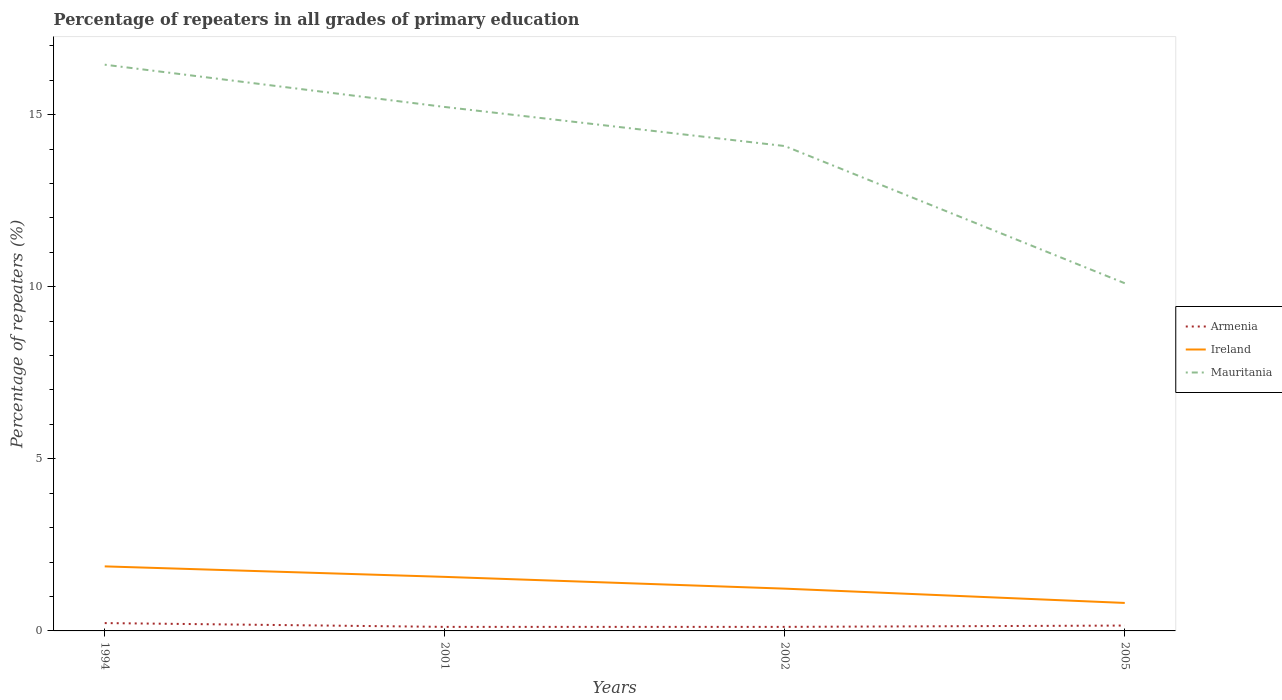Does the line corresponding to Ireland intersect with the line corresponding to Mauritania?
Give a very brief answer. No. Across all years, what is the maximum percentage of repeaters in Ireland?
Provide a short and direct response. 0.81. In which year was the percentage of repeaters in Ireland maximum?
Provide a short and direct response. 2005. What is the total percentage of repeaters in Ireland in the graph?
Make the answer very short. 0.3. What is the difference between the highest and the second highest percentage of repeaters in Ireland?
Your response must be concise. 1.06. What is the difference between the highest and the lowest percentage of repeaters in Ireland?
Ensure brevity in your answer.  2. How many lines are there?
Make the answer very short. 3. What is the difference between two consecutive major ticks on the Y-axis?
Offer a terse response. 5. Does the graph contain grids?
Ensure brevity in your answer.  No. Where does the legend appear in the graph?
Offer a terse response. Center right. How many legend labels are there?
Keep it short and to the point. 3. What is the title of the graph?
Ensure brevity in your answer.  Percentage of repeaters in all grades of primary education. Does "Comoros" appear as one of the legend labels in the graph?
Keep it short and to the point. No. What is the label or title of the X-axis?
Your answer should be compact. Years. What is the label or title of the Y-axis?
Provide a succinct answer. Percentage of repeaters (%). What is the Percentage of repeaters (%) in Armenia in 1994?
Give a very brief answer. 0.23. What is the Percentage of repeaters (%) of Ireland in 1994?
Provide a succinct answer. 1.88. What is the Percentage of repeaters (%) of Mauritania in 1994?
Make the answer very short. 16.45. What is the Percentage of repeaters (%) of Armenia in 2001?
Offer a very short reply. 0.12. What is the Percentage of repeaters (%) of Ireland in 2001?
Provide a short and direct response. 1.57. What is the Percentage of repeaters (%) in Mauritania in 2001?
Provide a short and direct response. 15.22. What is the Percentage of repeaters (%) in Armenia in 2002?
Provide a short and direct response. 0.12. What is the Percentage of repeaters (%) of Ireland in 2002?
Keep it short and to the point. 1.23. What is the Percentage of repeaters (%) of Mauritania in 2002?
Ensure brevity in your answer.  14.09. What is the Percentage of repeaters (%) of Armenia in 2005?
Your answer should be very brief. 0.16. What is the Percentage of repeaters (%) of Ireland in 2005?
Your answer should be compact. 0.81. What is the Percentage of repeaters (%) in Mauritania in 2005?
Your response must be concise. 10.1. Across all years, what is the maximum Percentage of repeaters (%) in Armenia?
Provide a succinct answer. 0.23. Across all years, what is the maximum Percentage of repeaters (%) of Ireland?
Provide a short and direct response. 1.88. Across all years, what is the maximum Percentage of repeaters (%) in Mauritania?
Offer a very short reply. 16.45. Across all years, what is the minimum Percentage of repeaters (%) in Armenia?
Make the answer very short. 0.12. Across all years, what is the minimum Percentage of repeaters (%) of Ireland?
Give a very brief answer. 0.81. Across all years, what is the minimum Percentage of repeaters (%) of Mauritania?
Make the answer very short. 10.1. What is the total Percentage of repeaters (%) of Armenia in the graph?
Keep it short and to the point. 0.62. What is the total Percentage of repeaters (%) in Ireland in the graph?
Your answer should be compact. 5.49. What is the total Percentage of repeaters (%) of Mauritania in the graph?
Your response must be concise. 55.86. What is the difference between the Percentage of repeaters (%) of Armenia in 1994 and that in 2001?
Keep it short and to the point. 0.11. What is the difference between the Percentage of repeaters (%) in Ireland in 1994 and that in 2001?
Offer a very short reply. 0.3. What is the difference between the Percentage of repeaters (%) of Mauritania in 1994 and that in 2001?
Your response must be concise. 1.23. What is the difference between the Percentage of repeaters (%) in Armenia in 1994 and that in 2002?
Your answer should be very brief. 0.11. What is the difference between the Percentage of repeaters (%) of Ireland in 1994 and that in 2002?
Your answer should be compact. 0.65. What is the difference between the Percentage of repeaters (%) of Mauritania in 1994 and that in 2002?
Give a very brief answer. 2.36. What is the difference between the Percentage of repeaters (%) of Armenia in 1994 and that in 2005?
Your answer should be compact. 0.07. What is the difference between the Percentage of repeaters (%) of Ireland in 1994 and that in 2005?
Your answer should be very brief. 1.06. What is the difference between the Percentage of repeaters (%) of Mauritania in 1994 and that in 2005?
Ensure brevity in your answer.  6.35. What is the difference between the Percentage of repeaters (%) in Armenia in 2001 and that in 2002?
Offer a terse response. -0. What is the difference between the Percentage of repeaters (%) in Ireland in 2001 and that in 2002?
Provide a short and direct response. 0.34. What is the difference between the Percentage of repeaters (%) of Mauritania in 2001 and that in 2002?
Your answer should be very brief. 1.14. What is the difference between the Percentage of repeaters (%) in Armenia in 2001 and that in 2005?
Your response must be concise. -0.04. What is the difference between the Percentage of repeaters (%) of Ireland in 2001 and that in 2005?
Give a very brief answer. 0.76. What is the difference between the Percentage of repeaters (%) in Mauritania in 2001 and that in 2005?
Give a very brief answer. 5.12. What is the difference between the Percentage of repeaters (%) in Armenia in 2002 and that in 2005?
Your response must be concise. -0.04. What is the difference between the Percentage of repeaters (%) in Ireland in 2002 and that in 2005?
Offer a terse response. 0.42. What is the difference between the Percentage of repeaters (%) in Mauritania in 2002 and that in 2005?
Keep it short and to the point. 3.99. What is the difference between the Percentage of repeaters (%) in Armenia in 1994 and the Percentage of repeaters (%) in Ireland in 2001?
Ensure brevity in your answer.  -1.34. What is the difference between the Percentage of repeaters (%) of Armenia in 1994 and the Percentage of repeaters (%) of Mauritania in 2001?
Ensure brevity in your answer.  -14.99. What is the difference between the Percentage of repeaters (%) of Ireland in 1994 and the Percentage of repeaters (%) of Mauritania in 2001?
Make the answer very short. -13.35. What is the difference between the Percentage of repeaters (%) of Armenia in 1994 and the Percentage of repeaters (%) of Ireland in 2002?
Keep it short and to the point. -1. What is the difference between the Percentage of repeaters (%) of Armenia in 1994 and the Percentage of repeaters (%) of Mauritania in 2002?
Keep it short and to the point. -13.86. What is the difference between the Percentage of repeaters (%) of Ireland in 1994 and the Percentage of repeaters (%) of Mauritania in 2002?
Your answer should be compact. -12.21. What is the difference between the Percentage of repeaters (%) of Armenia in 1994 and the Percentage of repeaters (%) of Ireland in 2005?
Keep it short and to the point. -0.59. What is the difference between the Percentage of repeaters (%) in Armenia in 1994 and the Percentage of repeaters (%) in Mauritania in 2005?
Offer a very short reply. -9.87. What is the difference between the Percentage of repeaters (%) of Ireland in 1994 and the Percentage of repeaters (%) of Mauritania in 2005?
Ensure brevity in your answer.  -8.23. What is the difference between the Percentage of repeaters (%) of Armenia in 2001 and the Percentage of repeaters (%) of Ireland in 2002?
Your answer should be compact. -1.11. What is the difference between the Percentage of repeaters (%) of Armenia in 2001 and the Percentage of repeaters (%) of Mauritania in 2002?
Your answer should be very brief. -13.97. What is the difference between the Percentage of repeaters (%) in Ireland in 2001 and the Percentage of repeaters (%) in Mauritania in 2002?
Provide a short and direct response. -12.52. What is the difference between the Percentage of repeaters (%) in Armenia in 2001 and the Percentage of repeaters (%) in Ireland in 2005?
Ensure brevity in your answer.  -0.7. What is the difference between the Percentage of repeaters (%) of Armenia in 2001 and the Percentage of repeaters (%) of Mauritania in 2005?
Ensure brevity in your answer.  -9.98. What is the difference between the Percentage of repeaters (%) of Ireland in 2001 and the Percentage of repeaters (%) of Mauritania in 2005?
Your answer should be very brief. -8.53. What is the difference between the Percentage of repeaters (%) of Armenia in 2002 and the Percentage of repeaters (%) of Ireland in 2005?
Keep it short and to the point. -0.7. What is the difference between the Percentage of repeaters (%) of Armenia in 2002 and the Percentage of repeaters (%) of Mauritania in 2005?
Make the answer very short. -9.98. What is the difference between the Percentage of repeaters (%) of Ireland in 2002 and the Percentage of repeaters (%) of Mauritania in 2005?
Ensure brevity in your answer.  -8.87. What is the average Percentage of repeaters (%) in Armenia per year?
Keep it short and to the point. 0.15. What is the average Percentage of repeaters (%) in Ireland per year?
Provide a succinct answer. 1.37. What is the average Percentage of repeaters (%) in Mauritania per year?
Your answer should be compact. 13.96. In the year 1994, what is the difference between the Percentage of repeaters (%) in Armenia and Percentage of repeaters (%) in Ireland?
Provide a short and direct response. -1.65. In the year 1994, what is the difference between the Percentage of repeaters (%) of Armenia and Percentage of repeaters (%) of Mauritania?
Your response must be concise. -16.22. In the year 1994, what is the difference between the Percentage of repeaters (%) of Ireland and Percentage of repeaters (%) of Mauritania?
Your answer should be compact. -14.57. In the year 2001, what is the difference between the Percentage of repeaters (%) of Armenia and Percentage of repeaters (%) of Ireland?
Offer a terse response. -1.45. In the year 2001, what is the difference between the Percentage of repeaters (%) in Armenia and Percentage of repeaters (%) in Mauritania?
Give a very brief answer. -15.1. In the year 2001, what is the difference between the Percentage of repeaters (%) in Ireland and Percentage of repeaters (%) in Mauritania?
Your answer should be very brief. -13.65. In the year 2002, what is the difference between the Percentage of repeaters (%) in Armenia and Percentage of repeaters (%) in Ireland?
Keep it short and to the point. -1.11. In the year 2002, what is the difference between the Percentage of repeaters (%) in Armenia and Percentage of repeaters (%) in Mauritania?
Give a very brief answer. -13.97. In the year 2002, what is the difference between the Percentage of repeaters (%) in Ireland and Percentage of repeaters (%) in Mauritania?
Give a very brief answer. -12.86. In the year 2005, what is the difference between the Percentage of repeaters (%) of Armenia and Percentage of repeaters (%) of Ireland?
Provide a short and direct response. -0.66. In the year 2005, what is the difference between the Percentage of repeaters (%) in Armenia and Percentage of repeaters (%) in Mauritania?
Ensure brevity in your answer.  -9.94. In the year 2005, what is the difference between the Percentage of repeaters (%) in Ireland and Percentage of repeaters (%) in Mauritania?
Your answer should be compact. -9.29. What is the ratio of the Percentage of repeaters (%) in Armenia in 1994 to that in 2001?
Offer a terse response. 1.94. What is the ratio of the Percentage of repeaters (%) in Ireland in 1994 to that in 2001?
Ensure brevity in your answer.  1.19. What is the ratio of the Percentage of repeaters (%) of Mauritania in 1994 to that in 2001?
Keep it short and to the point. 1.08. What is the ratio of the Percentage of repeaters (%) of Armenia in 1994 to that in 2002?
Your response must be concise. 1.93. What is the ratio of the Percentage of repeaters (%) of Ireland in 1994 to that in 2002?
Your response must be concise. 1.53. What is the ratio of the Percentage of repeaters (%) of Mauritania in 1994 to that in 2002?
Your response must be concise. 1.17. What is the ratio of the Percentage of repeaters (%) in Armenia in 1994 to that in 2005?
Ensure brevity in your answer.  1.46. What is the ratio of the Percentage of repeaters (%) of Ireland in 1994 to that in 2005?
Keep it short and to the point. 2.31. What is the ratio of the Percentage of repeaters (%) in Mauritania in 1994 to that in 2005?
Make the answer very short. 1.63. What is the ratio of the Percentage of repeaters (%) of Ireland in 2001 to that in 2002?
Provide a succinct answer. 1.28. What is the ratio of the Percentage of repeaters (%) in Mauritania in 2001 to that in 2002?
Ensure brevity in your answer.  1.08. What is the ratio of the Percentage of repeaters (%) of Armenia in 2001 to that in 2005?
Offer a very short reply. 0.75. What is the ratio of the Percentage of repeaters (%) in Ireland in 2001 to that in 2005?
Offer a very short reply. 1.93. What is the ratio of the Percentage of repeaters (%) of Mauritania in 2001 to that in 2005?
Give a very brief answer. 1.51. What is the ratio of the Percentage of repeaters (%) in Armenia in 2002 to that in 2005?
Provide a short and direct response. 0.76. What is the ratio of the Percentage of repeaters (%) of Ireland in 2002 to that in 2005?
Your answer should be very brief. 1.51. What is the ratio of the Percentage of repeaters (%) in Mauritania in 2002 to that in 2005?
Provide a succinct answer. 1.39. What is the difference between the highest and the second highest Percentage of repeaters (%) of Armenia?
Make the answer very short. 0.07. What is the difference between the highest and the second highest Percentage of repeaters (%) in Ireland?
Your answer should be very brief. 0.3. What is the difference between the highest and the second highest Percentage of repeaters (%) of Mauritania?
Your answer should be compact. 1.23. What is the difference between the highest and the lowest Percentage of repeaters (%) of Armenia?
Your answer should be compact. 0.11. What is the difference between the highest and the lowest Percentage of repeaters (%) of Ireland?
Make the answer very short. 1.06. What is the difference between the highest and the lowest Percentage of repeaters (%) of Mauritania?
Provide a succinct answer. 6.35. 